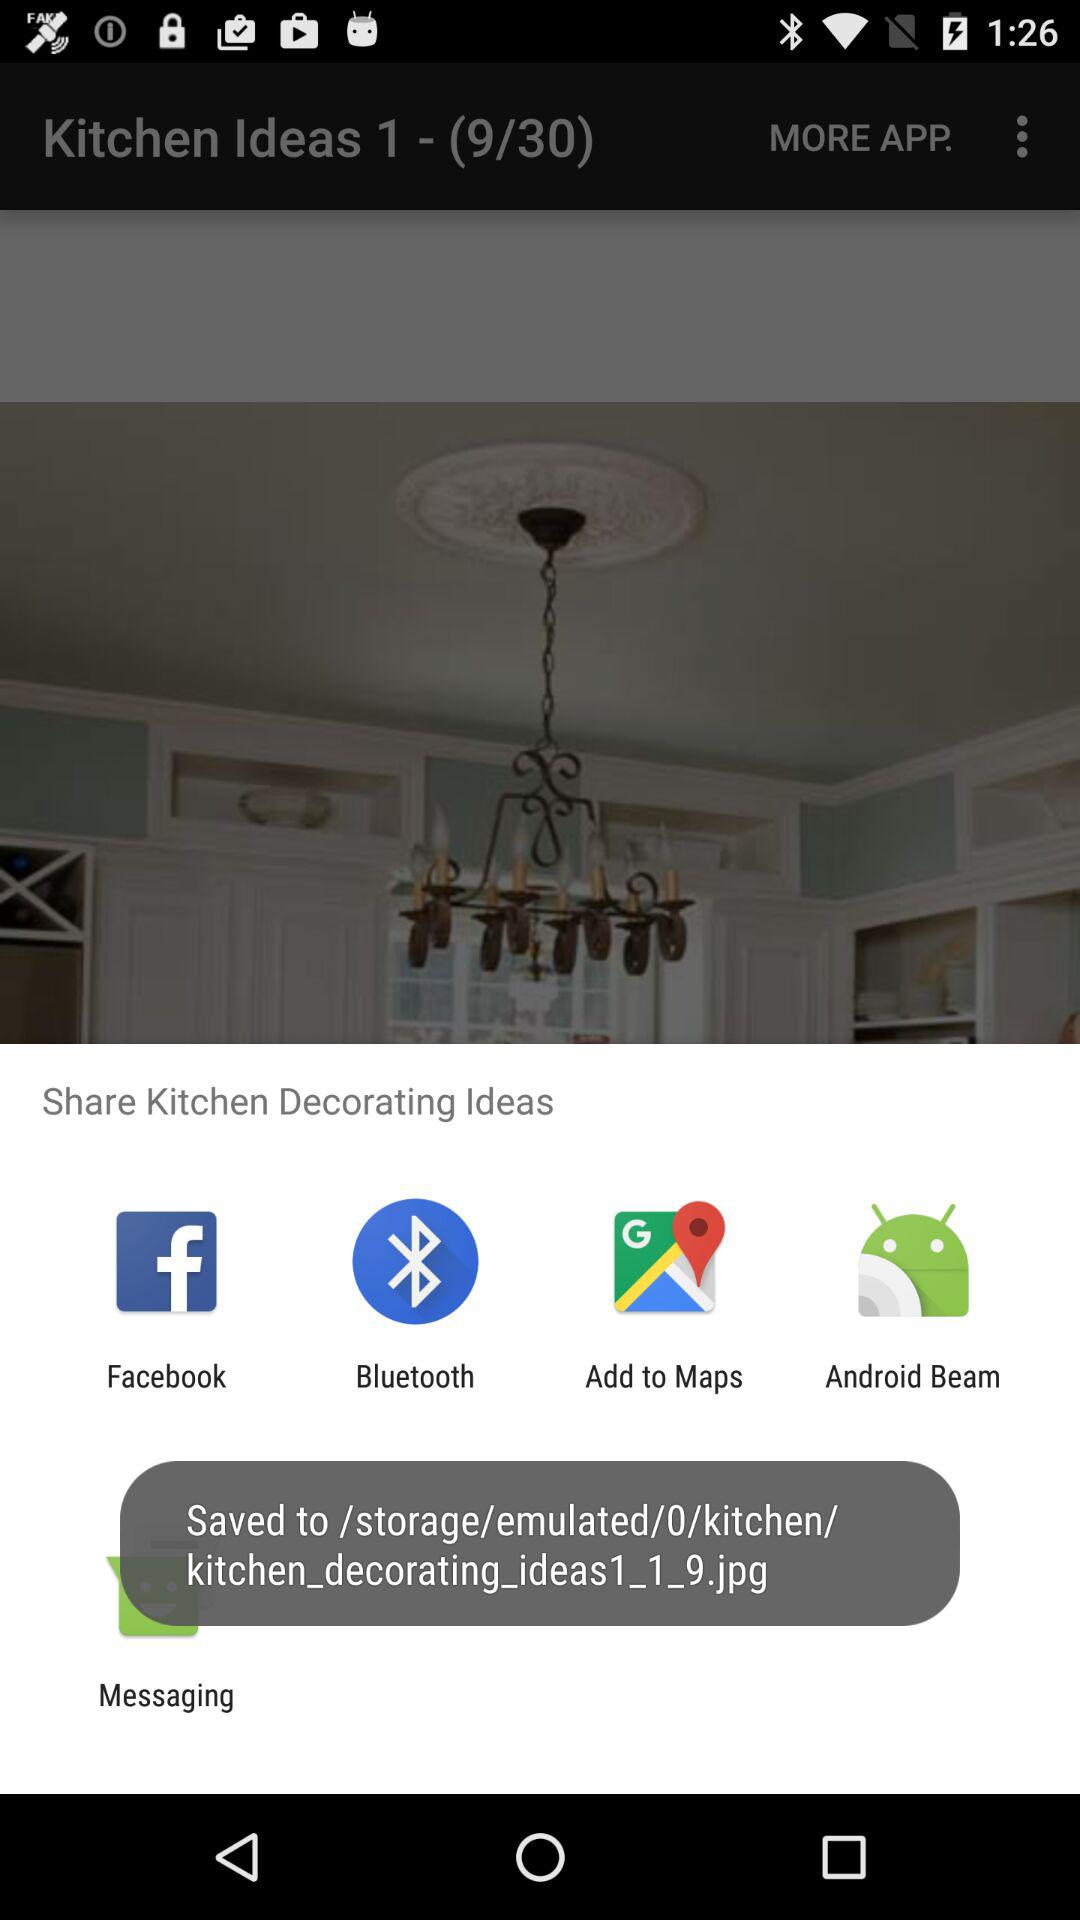How many images in total are there? There are 30 images in total. 